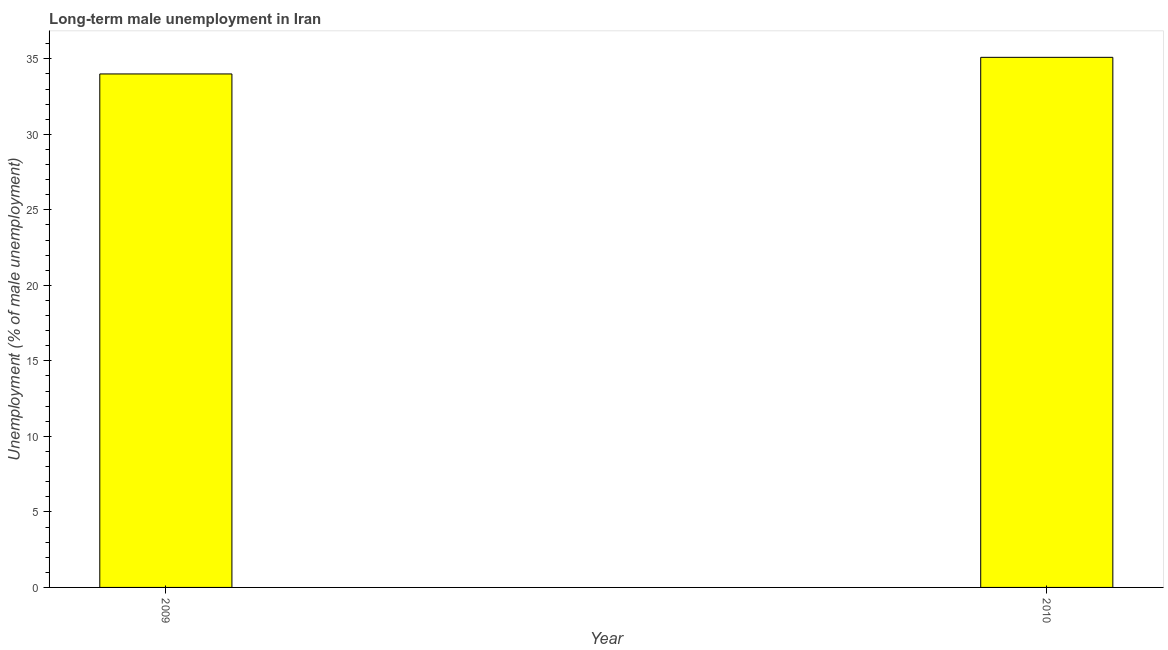Does the graph contain grids?
Provide a succinct answer. No. What is the title of the graph?
Ensure brevity in your answer.  Long-term male unemployment in Iran. What is the label or title of the Y-axis?
Provide a succinct answer. Unemployment (% of male unemployment). Across all years, what is the maximum long-term male unemployment?
Offer a terse response. 35.1. In which year was the long-term male unemployment maximum?
Provide a short and direct response. 2010. What is the sum of the long-term male unemployment?
Your answer should be very brief. 69.1. What is the difference between the long-term male unemployment in 2009 and 2010?
Provide a short and direct response. -1.1. What is the average long-term male unemployment per year?
Give a very brief answer. 34.55. What is the median long-term male unemployment?
Offer a very short reply. 34.55. In how many years, is the long-term male unemployment greater than 28 %?
Your response must be concise. 2. Do a majority of the years between 2009 and 2010 (inclusive) have long-term male unemployment greater than 4 %?
Give a very brief answer. Yes. What is the ratio of the long-term male unemployment in 2009 to that in 2010?
Ensure brevity in your answer.  0.97. Is the long-term male unemployment in 2009 less than that in 2010?
Give a very brief answer. Yes. In how many years, is the long-term male unemployment greater than the average long-term male unemployment taken over all years?
Offer a terse response. 1. Are all the bars in the graph horizontal?
Keep it short and to the point. No. What is the difference between two consecutive major ticks on the Y-axis?
Your answer should be very brief. 5. Are the values on the major ticks of Y-axis written in scientific E-notation?
Give a very brief answer. No. What is the Unemployment (% of male unemployment) in 2010?
Ensure brevity in your answer.  35.1. What is the ratio of the Unemployment (% of male unemployment) in 2009 to that in 2010?
Give a very brief answer. 0.97. 